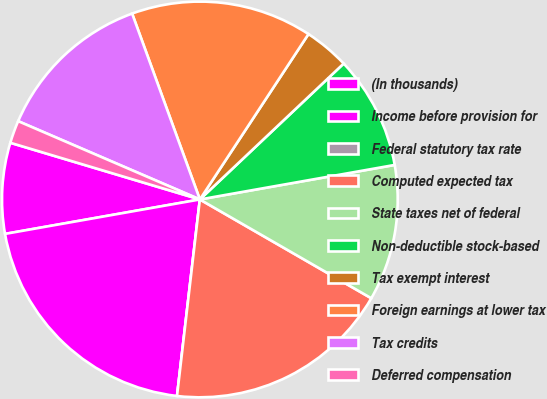<chart> <loc_0><loc_0><loc_500><loc_500><pie_chart><fcel>(In thousands)<fcel>Income before provision for<fcel>Federal statutory tax rate<fcel>Computed expected tax<fcel>State taxes net of federal<fcel>Non-deductible stock-based<fcel>Tax exempt interest<fcel>Foreign earnings at lower tax<fcel>Tax credits<fcel>Deferred compensation<nl><fcel>7.41%<fcel>20.37%<fcel>0.0%<fcel>18.52%<fcel>11.11%<fcel>9.26%<fcel>3.7%<fcel>14.81%<fcel>12.96%<fcel>1.85%<nl></chart> 